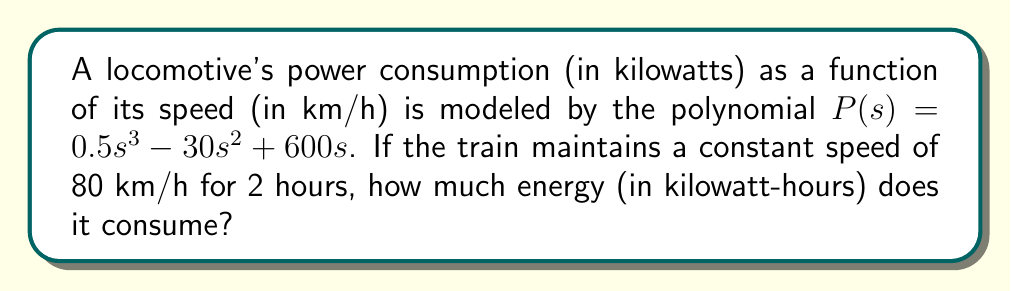What is the answer to this math problem? To solve this problem, we'll follow these steps:

1) First, we need to find the power consumption at 80 km/h:
   
   $P(80) = 0.5(80)^3 - 30(80)^2 + 600(80)$
   
   $= 0.5(512000) - 30(6400) + 600(80)$
   
   $= 256000 - 192000 + 48000$
   
   $= 112000$ kW

2) Now that we know the power consumption is 112000 kW, and the train maintains this speed for 2 hours, we can calculate the energy consumed:

   Energy = Power × Time
   
   $E = 112000 \text{ kW} \times 2 \text{ h}$
   
   $= 224000 \text{ kWh}$

Therefore, the locomotive consumes 224000 kilowatt-hours of energy during the 2-hour journey at 80 km/h.
Answer: 224000 kWh 